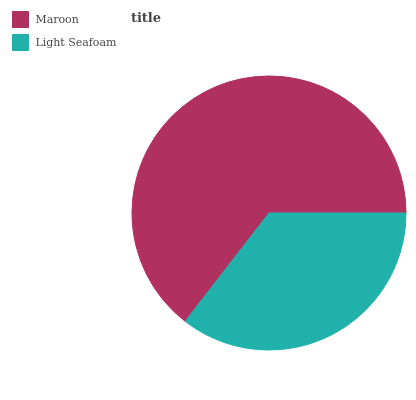Is Light Seafoam the minimum?
Answer yes or no. Yes. Is Maroon the maximum?
Answer yes or no. Yes. Is Light Seafoam the maximum?
Answer yes or no. No. Is Maroon greater than Light Seafoam?
Answer yes or no. Yes. Is Light Seafoam less than Maroon?
Answer yes or no. Yes. Is Light Seafoam greater than Maroon?
Answer yes or no. No. Is Maroon less than Light Seafoam?
Answer yes or no. No. Is Maroon the high median?
Answer yes or no. Yes. Is Light Seafoam the low median?
Answer yes or no. Yes. Is Light Seafoam the high median?
Answer yes or no. No. Is Maroon the low median?
Answer yes or no. No. 